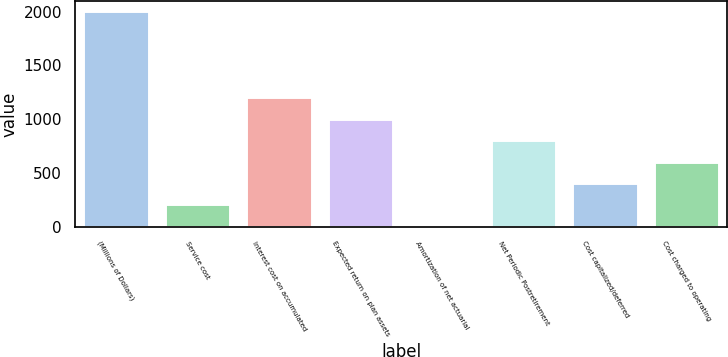Convert chart to OTSL. <chart><loc_0><loc_0><loc_500><loc_500><bar_chart><fcel>(Millions of Dollars)<fcel>Service cost<fcel>Interest cost on accumulated<fcel>Expected return on plan assets<fcel>Amortization of net actuarial<fcel>Net Periodic Postretirement<fcel>Cost capitalized/deferred<fcel>Cost charged to operating<nl><fcel>2001<fcel>209.1<fcel>1204.6<fcel>1005.5<fcel>10<fcel>806.4<fcel>408.2<fcel>607.3<nl></chart> 